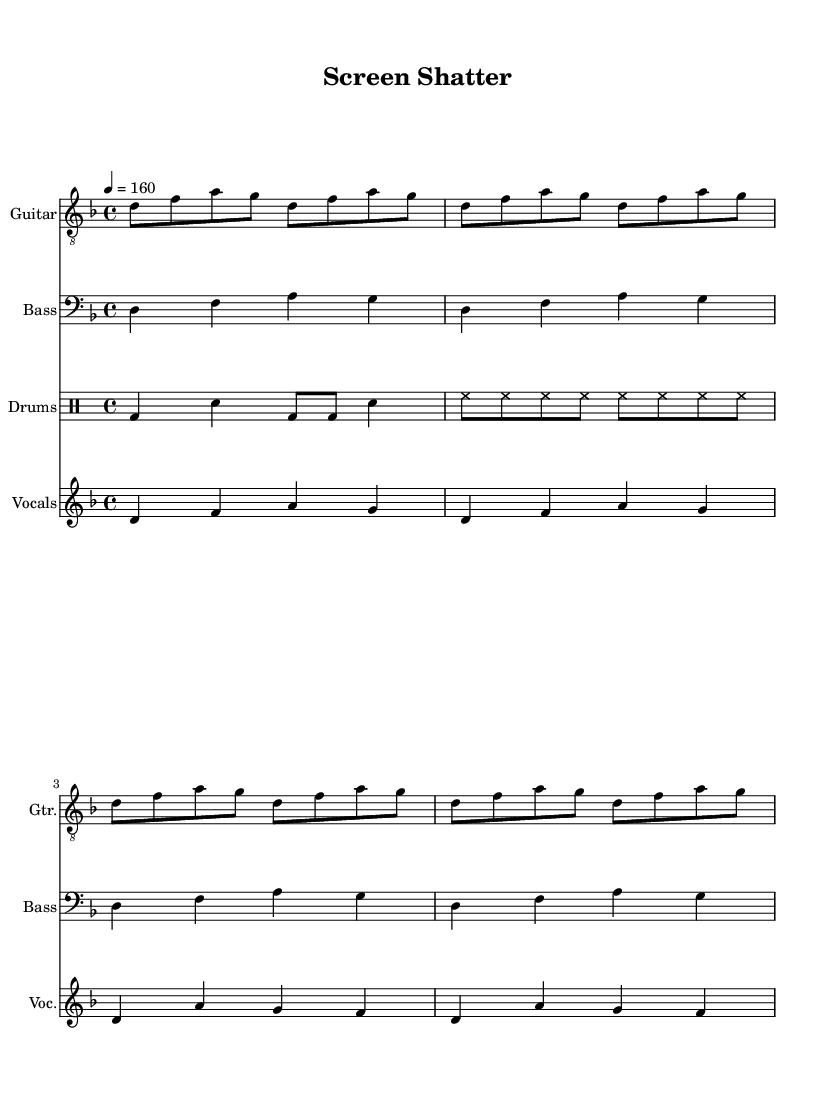What is the key signature of this music? The key signature is D minor, indicated by one flat (B flat) in the key signature section at the beginning of the piece.
Answer: D minor What is the time signature of this music? The time signature is 4/4, which is noted at the beginning of the score and shows there are four beats in a measure.
Answer: 4/4 What is the tempo marking for this piece? The tempo is marked at 160 beats per minute, shown by the number beside "tempo" in the global tempo section.
Answer: 160 How many measures are in the guitar part? The guitar part has a total of 16 measures, as indicated by the repeated guitar riff across the score, each repetition covers four measures.
Answer: 16 Which instrument plays the bass line? The bass line is played by the instrument labeled "Bass," as shown at the beginning of that part in the score.
Answer: Bass Describe the style of the vocal melody based on the pitch range. The vocal melody predominantly oscillates between notes, creating a mix of ascending and descending phrases that commonly characterize punk vocal styles.
Answer: Ascending and descending How does the drum pattern contribute to the punk style? The drum pattern features a strong emphasis on the bass drum and snare with consistent hi-hat rhythms, which are typical elements of punk music that drive energy and intensity.
Answer: Strong energy 